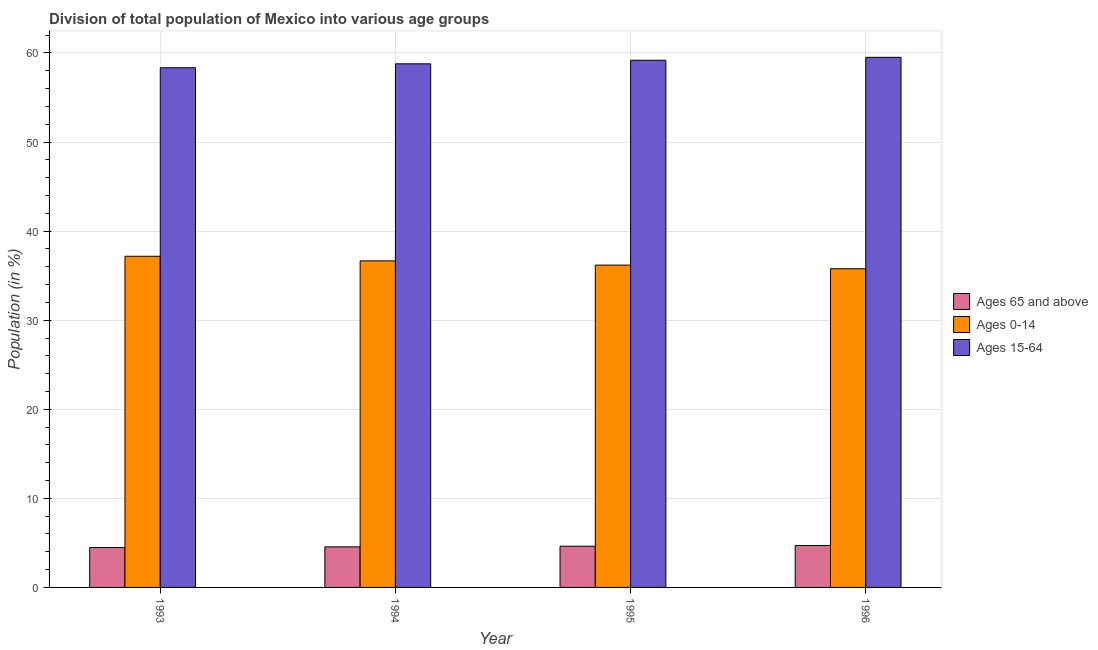How many different coloured bars are there?
Your answer should be very brief. 3. What is the label of the 1st group of bars from the left?
Your answer should be very brief. 1993. In how many cases, is the number of bars for a given year not equal to the number of legend labels?
Provide a short and direct response. 0. What is the percentage of population within the age-group 15-64 in 1995?
Provide a short and direct response. 59.18. Across all years, what is the maximum percentage of population within the age-group of 65 and above?
Offer a very short reply. 4.71. Across all years, what is the minimum percentage of population within the age-group 15-64?
Provide a short and direct response. 58.34. In which year was the percentage of population within the age-group 0-14 maximum?
Give a very brief answer. 1993. What is the total percentage of population within the age-group 15-64 in the graph?
Offer a terse response. 235.83. What is the difference between the percentage of population within the age-group 0-14 in 1995 and that in 1996?
Ensure brevity in your answer.  0.41. What is the difference between the percentage of population within the age-group of 65 and above in 1995 and the percentage of population within the age-group 0-14 in 1994?
Your answer should be very brief. 0.08. What is the average percentage of population within the age-group of 65 and above per year?
Provide a succinct answer. 4.59. In the year 1994, what is the difference between the percentage of population within the age-group 15-64 and percentage of population within the age-group 0-14?
Give a very brief answer. 0. In how many years, is the percentage of population within the age-group 15-64 greater than 14 %?
Make the answer very short. 4. What is the ratio of the percentage of population within the age-group 0-14 in 1993 to that in 1995?
Your response must be concise. 1.03. Is the percentage of population within the age-group of 65 and above in 1995 less than that in 1996?
Make the answer very short. Yes. What is the difference between the highest and the second highest percentage of population within the age-group 15-64?
Give a very brief answer. 0.33. What is the difference between the highest and the lowest percentage of population within the age-group 15-64?
Keep it short and to the point. 1.17. In how many years, is the percentage of population within the age-group 0-14 greater than the average percentage of population within the age-group 0-14 taken over all years?
Provide a short and direct response. 2. What does the 1st bar from the left in 1995 represents?
Provide a short and direct response. Ages 65 and above. What does the 2nd bar from the right in 1994 represents?
Give a very brief answer. Ages 0-14. Are all the bars in the graph horizontal?
Keep it short and to the point. No. How many years are there in the graph?
Your response must be concise. 4. Does the graph contain any zero values?
Provide a short and direct response. No. Does the graph contain grids?
Provide a short and direct response. Yes. How many legend labels are there?
Keep it short and to the point. 3. How are the legend labels stacked?
Your response must be concise. Vertical. What is the title of the graph?
Keep it short and to the point. Division of total population of Mexico into various age groups
. Does "Renewable sources" appear as one of the legend labels in the graph?
Provide a succinct answer. No. What is the label or title of the X-axis?
Your response must be concise. Year. What is the Population (in %) of Ages 65 and above in 1993?
Your answer should be very brief. 4.48. What is the Population (in %) in Ages 0-14 in 1993?
Offer a terse response. 37.18. What is the Population (in %) in Ages 15-64 in 1993?
Offer a terse response. 58.34. What is the Population (in %) of Ages 65 and above in 1994?
Offer a very short reply. 4.55. What is the Population (in %) in Ages 0-14 in 1994?
Your answer should be compact. 36.66. What is the Population (in %) of Ages 15-64 in 1994?
Your answer should be very brief. 58.78. What is the Population (in %) in Ages 65 and above in 1995?
Your answer should be very brief. 4.63. What is the Population (in %) of Ages 0-14 in 1995?
Provide a succinct answer. 36.19. What is the Population (in %) of Ages 15-64 in 1995?
Ensure brevity in your answer.  59.18. What is the Population (in %) in Ages 65 and above in 1996?
Make the answer very short. 4.71. What is the Population (in %) of Ages 0-14 in 1996?
Provide a succinct answer. 35.78. What is the Population (in %) in Ages 15-64 in 1996?
Give a very brief answer. 59.51. Across all years, what is the maximum Population (in %) of Ages 65 and above?
Offer a very short reply. 4.71. Across all years, what is the maximum Population (in %) of Ages 0-14?
Ensure brevity in your answer.  37.18. Across all years, what is the maximum Population (in %) of Ages 15-64?
Your response must be concise. 59.51. Across all years, what is the minimum Population (in %) in Ages 65 and above?
Your response must be concise. 4.48. Across all years, what is the minimum Population (in %) of Ages 0-14?
Your response must be concise. 35.78. Across all years, what is the minimum Population (in %) of Ages 15-64?
Provide a short and direct response. 58.34. What is the total Population (in %) in Ages 65 and above in the graph?
Your answer should be very brief. 18.37. What is the total Population (in %) of Ages 0-14 in the graph?
Your answer should be very brief. 145.81. What is the total Population (in %) of Ages 15-64 in the graph?
Your answer should be compact. 235.83. What is the difference between the Population (in %) of Ages 65 and above in 1993 and that in 1994?
Offer a very short reply. -0.08. What is the difference between the Population (in %) in Ages 0-14 in 1993 and that in 1994?
Your response must be concise. 0.52. What is the difference between the Population (in %) in Ages 15-64 in 1993 and that in 1994?
Offer a terse response. -0.44. What is the difference between the Population (in %) in Ages 65 and above in 1993 and that in 1995?
Provide a short and direct response. -0.15. What is the difference between the Population (in %) of Ages 15-64 in 1993 and that in 1995?
Make the answer very short. -0.84. What is the difference between the Population (in %) in Ages 65 and above in 1993 and that in 1996?
Your answer should be compact. -0.23. What is the difference between the Population (in %) in Ages 0-14 in 1993 and that in 1996?
Give a very brief answer. 1.4. What is the difference between the Population (in %) of Ages 15-64 in 1993 and that in 1996?
Give a very brief answer. -1.17. What is the difference between the Population (in %) of Ages 65 and above in 1994 and that in 1995?
Your answer should be very brief. -0.08. What is the difference between the Population (in %) of Ages 0-14 in 1994 and that in 1995?
Give a very brief answer. 0.48. What is the difference between the Population (in %) in Ages 15-64 in 1994 and that in 1995?
Offer a very short reply. -0.4. What is the difference between the Population (in %) in Ages 65 and above in 1994 and that in 1996?
Your answer should be compact. -0.15. What is the difference between the Population (in %) in Ages 0-14 in 1994 and that in 1996?
Your answer should be very brief. 0.88. What is the difference between the Population (in %) in Ages 15-64 in 1994 and that in 1996?
Provide a succinct answer. -0.73. What is the difference between the Population (in %) in Ages 65 and above in 1995 and that in 1996?
Give a very brief answer. -0.08. What is the difference between the Population (in %) in Ages 0-14 in 1995 and that in 1996?
Offer a terse response. 0.41. What is the difference between the Population (in %) in Ages 15-64 in 1995 and that in 1996?
Provide a succinct answer. -0.33. What is the difference between the Population (in %) in Ages 65 and above in 1993 and the Population (in %) in Ages 0-14 in 1994?
Ensure brevity in your answer.  -32.19. What is the difference between the Population (in %) of Ages 65 and above in 1993 and the Population (in %) of Ages 15-64 in 1994?
Offer a very short reply. -54.31. What is the difference between the Population (in %) in Ages 0-14 in 1993 and the Population (in %) in Ages 15-64 in 1994?
Your response must be concise. -21.61. What is the difference between the Population (in %) in Ages 65 and above in 1993 and the Population (in %) in Ages 0-14 in 1995?
Offer a terse response. -31.71. What is the difference between the Population (in %) of Ages 65 and above in 1993 and the Population (in %) of Ages 15-64 in 1995?
Give a very brief answer. -54.71. What is the difference between the Population (in %) of Ages 0-14 in 1993 and the Population (in %) of Ages 15-64 in 1995?
Provide a short and direct response. -22.01. What is the difference between the Population (in %) of Ages 65 and above in 1993 and the Population (in %) of Ages 0-14 in 1996?
Keep it short and to the point. -31.3. What is the difference between the Population (in %) in Ages 65 and above in 1993 and the Population (in %) in Ages 15-64 in 1996?
Offer a very short reply. -55.04. What is the difference between the Population (in %) of Ages 0-14 in 1993 and the Population (in %) of Ages 15-64 in 1996?
Keep it short and to the point. -22.34. What is the difference between the Population (in %) in Ages 65 and above in 1994 and the Population (in %) in Ages 0-14 in 1995?
Provide a succinct answer. -31.63. What is the difference between the Population (in %) in Ages 65 and above in 1994 and the Population (in %) in Ages 15-64 in 1995?
Give a very brief answer. -54.63. What is the difference between the Population (in %) of Ages 0-14 in 1994 and the Population (in %) of Ages 15-64 in 1995?
Your answer should be very brief. -22.52. What is the difference between the Population (in %) of Ages 65 and above in 1994 and the Population (in %) of Ages 0-14 in 1996?
Your answer should be compact. -31.23. What is the difference between the Population (in %) of Ages 65 and above in 1994 and the Population (in %) of Ages 15-64 in 1996?
Make the answer very short. -54.96. What is the difference between the Population (in %) of Ages 0-14 in 1994 and the Population (in %) of Ages 15-64 in 1996?
Your response must be concise. -22.85. What is the difference between the Population (in %) in Ages 65 and above in 1995 and the Population (in %) in Ages 0-14 in 1996?
Ensure brevity in your answer.  -31.15. What is the difference between the Population (in %) of Ages 65 and above in 1995 and the Population (in %) of Ages 15-64 in 1996?
Make the answer very short. -54.89. What is the difference between the Population (in %) of Ages 0-14 in 1995 and the Population (in %) of Ages 15-64 in 1996?
Provide a succinct answer. -23.33. What is the average Population (in %) in Ages 65 and above per year?
Your response must be concise. 4.59. What is the average Population (in %) in Ages 0-14 per year?
Give a very brief answer. 36.45. What is the average Population (in %) in Ages 15-64 per year?
Your response must be concise. 58.96. In the year 1993, what is the difference between the Population (in %) of Ages 65 and above and Population (in %) of Ages 0-14?
Offer a terse response. -32.7. In the year 1993, what is the difference between the Population (in %) of Ages 65 and above and Population (in %) of Ages 15-64?
Provide a succinct answer. -53.87. In the year 1993, what is the difference between the Population (in %) of Ages 0-14 and Population (in %) of Ages 15-64?
Your answer should be very brief. -21.16. In the year 1994, what is the difference between the Population (in %) of Ages 65 and above and Population (in %) of Ages 0-14?
Provide a short and direct response. -32.11. In the year 1994, what is the difference between the Population (in %) of Ages 65 and above and Population (in %) of Ages 15-64?
Your answer should be compact. -54.23. In the year 1994, what is the difference between the Population (in %) of Ages 0-14 and Population (in %) of Ages 15-64?
Provide a succinct answer. -22.12. In the year 1995, what is the difference between the Population (in %) in Ages 65 and above and Population (in %) in Ages 0-14?
Provide a short and direct response. -31.56. In the year 1995, what is the difference between the Population (in %) in Ages 65 and above and Population (in %) in Ages 15-64?
Provide a succinct answer. -54.56. In the year 1995, what is the difference between the Population (in %) in Ages 0-14 and Population (in %) in Ages 15-64?
Offer a very short reply. -23. In the year 1996, what is the difference between the Population (in %) of Ages 65 and above and Population (in %) of Ages 0-14?
Offer a terse response. -31.07. In the year 1996, what is the difference between the Population (in %) in Ages 65 and above and Population (in %) in Ages 15-64?
Offer a very short reply. -54.81. In the year 1996, what is the difference between the Population (in %) of Ages 0-14 and Population (in %) of Ages 15-64?
Offer a terse response. -23.74. What is the ratio of the Population (in %) of Ages 65 and above in 1993 to that in 1994?
Your answer should be compact. 0.98. What is the ratio of the Population (in %) of Ages 0-14 in 1993 to that in 1994?
Provide a succinct answer. 1.01. What is the ratio of the Population (in %) of Ages 15-64 in 1993 to that in 1994?
Keep it short and to the point. 0.99. What is the ratio of the Population (in %) of Ages 65 and above in 1993 to that in 1995?
Your answer should be very brief. 0.97. What is the ratio of the Population (in %) in Ages 0-14 in 1993 to that in 1995?
Keep it short and to the point. 1.03. What is the ratio of the Population (in %) of Ages 15-64 in 1993 to that in 1995?
Your response must be concise. 0.99. What is the ratio of the Population (in %) of Ages 65 and above in 1993 to that in 1996?
Provide a short and direct response. 0.95. What is the ratio of the Population (in %) in Ages 0-14 in 1993 to that in 1996?
Make the answer very short. 1.04. What is the ratio of the Population (in %) in Ages 15-64 in 1993 to that in 1996?
Make the answer very short. 0.98. What is the ratio of the Population (in %) in Ages 65 and above in 1994 to that in 1995?
Offer a terse response. 0.98. What is the ratio of the Population (in %) of Ages 0-14 in 1994 to that in 1995?
Offer a very short reply. 1.01. What is the ratio of the Population (in %) in Ages 65 and above in 1994 to that in 1996?
Keep it short and to the point. 0.97. What is the ratio of the Population (in %) of Ages 0-14 in 1994 to that in 1996?
Ensure brevity in your answer.  1.02. What is the ratio of the Population (in %) in Ages 15-64 in 1994 to that in 1996?
Give a very brief answer. 0.99. What is the ratio of the Population (in %) in Ages 65 and above in 1995 to that in 1996?
Give a very brief answer. 0.98. What is the ratio of the Population (in %) of Ages 0-14 in 1995 to that in 1996?
Offer a very short reply. 1.01. What is the difference between the highest and the second highest Population (in %) in Ages 65 and above?
Offer a very short reply. 0.08. What is the difference between the highest and the second highest Population (in %) of Ages 0-14?
Ensure brevity in your answer.  0.52. What is the difference between the highest and the second highest Population (in %) in Ages 15-64?
Provide a short and direct response. 0.33. What is the difference between the highest and the lowest Population (in %) in Ages 65 and above?
Your answer should be very brief. 0.23. What is the difference between the highest and the lowest Population (in %) in Ages 0-14?
Provide a succinct answer. 1.4. What is the difference between the highest and the lowest Population (in %) in Ages 15-64?
Provide a short and direct response. 1.17. 